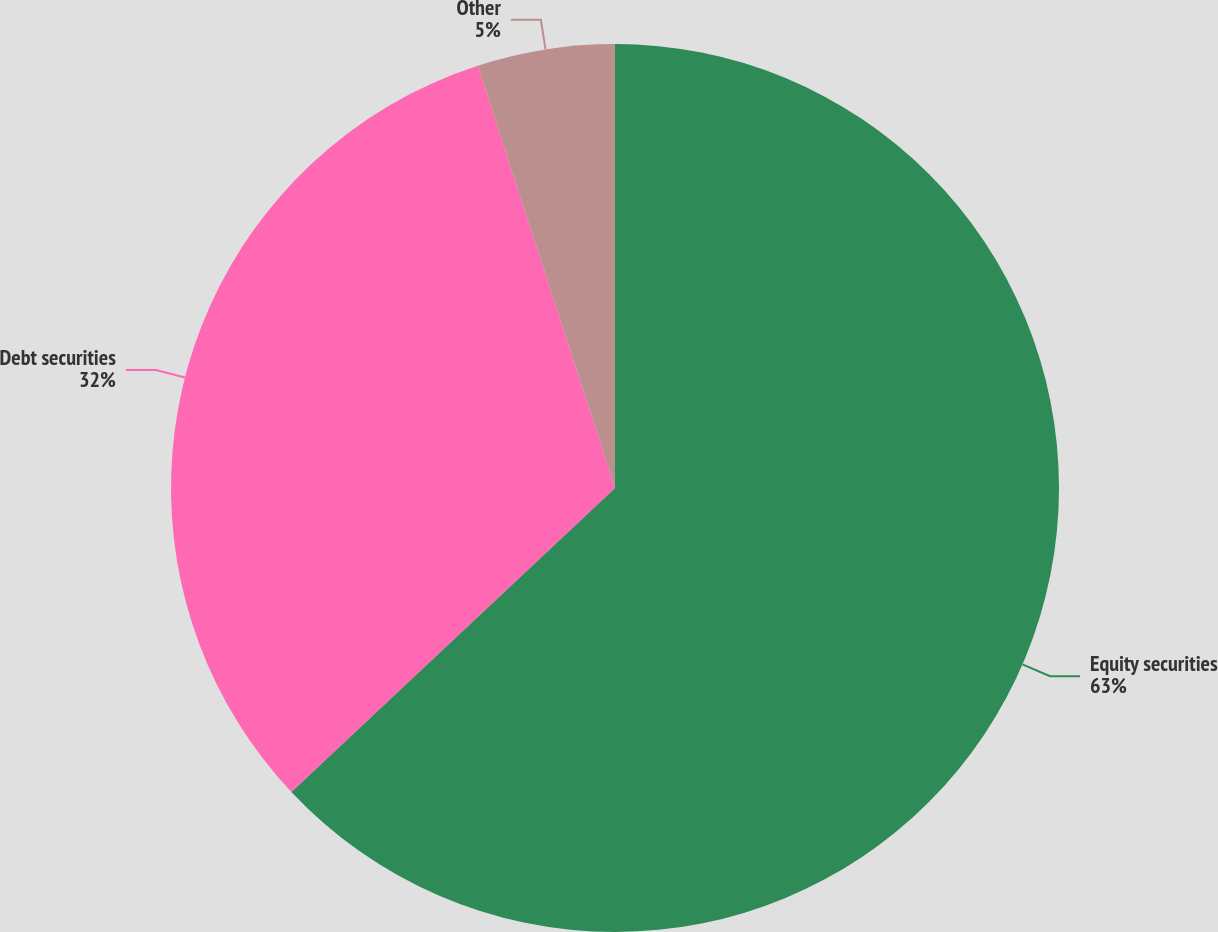Convert chart to OTSL. <chart><loc_0><loc_0><loc_500><loc_500><pie_chart><fcel>Equity securities<fcel>Debt securities<fcel>Other<nl><fcel>63.0%<fcel>32.0%<fcel>5.0%<nl></chart> 